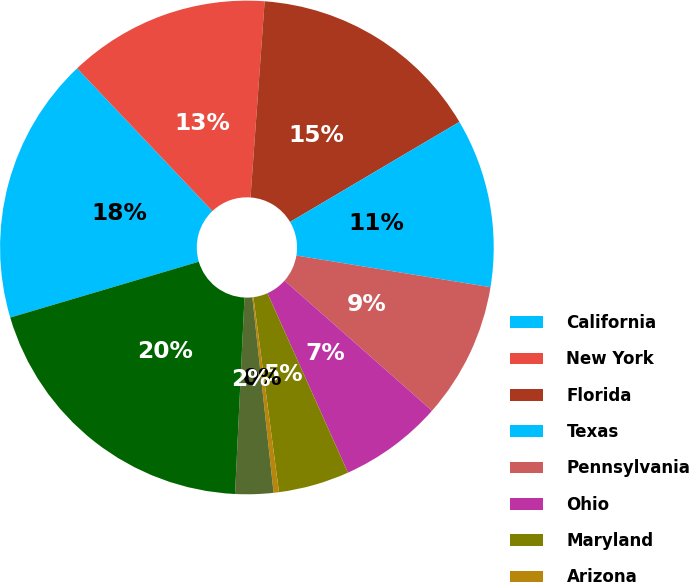Convert chart to OTSL. <chart><loc_0><loc_0><loc_500><loc_500><pie_chart><fcel>California<fcel>New York<fcel>Florida<fcel>Texas<fcel>Pennsylvania<fcel>Ohio<fcel>Maryland<fcel>Arizona<fcel>Colorado<fcel>Other states<nl><fcel>17.51%<fcel>13.22%<fcel>15.36%<fcel>11.07%<fcel>8.93%<fcel>6.78%<fcel>4.64%<fcel>0.35%<fcel>2.49%<fcel>19.65%<nl></chart> 